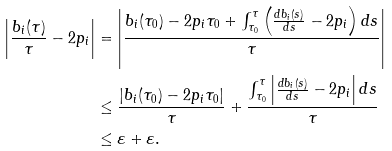<formula> <loc_0><loc_0><loc_500><loc_500>\left | \frac { b _ { i } ( \tau ) } { \tau } - 2 p _ { i } \right | & = \left | \frac { b _ { i } ( \tau _ { 0 } ) - 2 p _ { i } \tau _ { 0 } + \int _ { \tau _ { 0 } } ^ { \tau } \left ( \frac { d b _ { i } ( s ) } { d s } - 2 p _ { i } \right ) d s } { \tau } \right | \\ & \leq \frac { \left | b _ { i } ( \tau _ { 0 } ) - 2 p _ { i } \tau _ { 0 } \right | } { \tau } + \frac { \int _ { \tau _ { 0 } } ^ { \tau } \left | \frac { d b _ { i } ( s ) } { d s } - 2 p _ { i } \right | d s } { \tau } \\ & \leq \varepsilon + \varepsilon .</formula> 